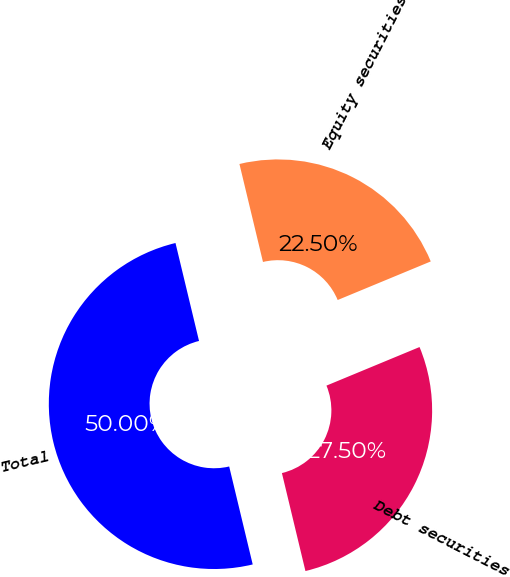<chart> <loc_0><loc_0><loc_500><loc_500><pie_chart><fcel>Equity securities<fcel>Debt securities<fcel>Total<nl><fcel>22.5%<fcel>27.5%<fcel>50.0%<nl></chart> 